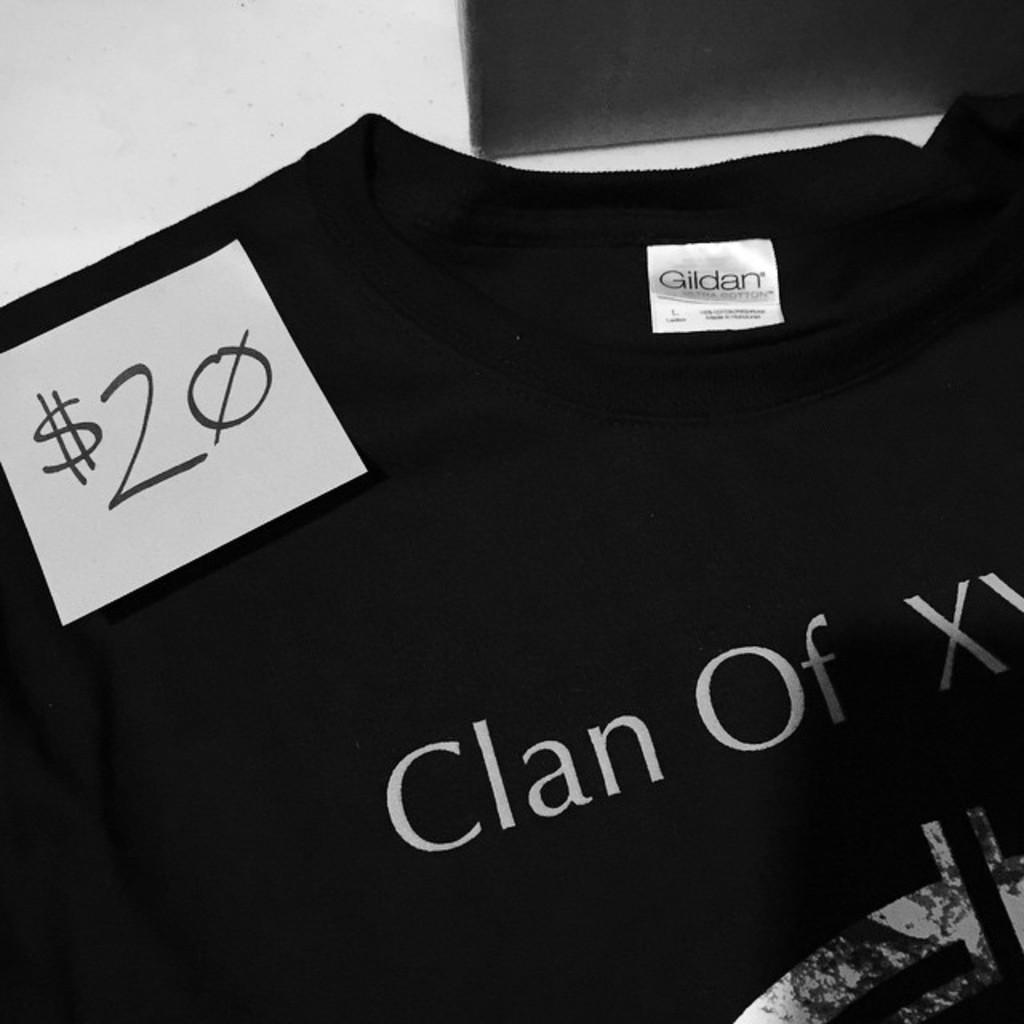What is the main subject of the image? The main subject of the image is a black t-shirt. What is on the t-shirt? There is a sticker on the t-shirt. What can be read on the sticker? There is writing on the sticker. What else can be seen in the image besides the t-shirt and sticker? There are objects visible in the background of the image. What type of error message is displayed on the t-shirt in the image? There is no error message displayed on the t-shirt in the image; it has a sticker with writing on it. How many slaves are depicted on the t-shirt in the image? There are no slaves depicted on the t-shirt in the image; it has a sticker with writing on it. 